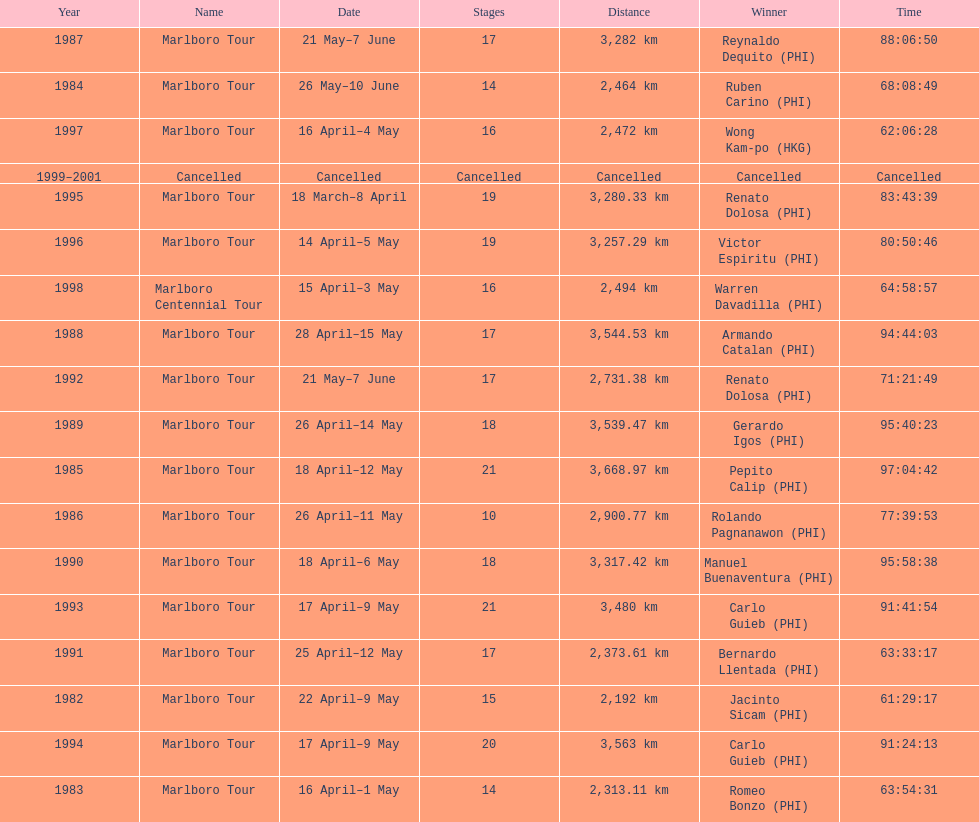How long did it take warren davadilla to complete the 1998 marlboro centennial tour? 64:58:57. 